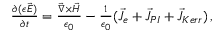Convert formula to latex. <formula><loc_0><loc_0><loc_500><loc_500>\begin{array} { r l r } } & { \frac { \partial { ( \epsilon \vec { E } ) } } { \partial { t } } = \frac { \vec { \nabla } \times \vec { H } } { \epsilon _ { 0 } } - \frac { 1 } { \epsilon _ { 0 } } ( \vec { J } _ { e } + \vec { J } _ { P I } + \vec { J } _ { K e r r } ) \, , } \end{array}</formula> 